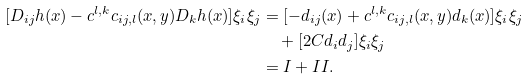Convert formula to latex. <formula><loc_0><loc_0><loc_500><loc_500>[ D _ { i j } h ( x ) - c ^ { l , k } c _ { i j , l } ( x , y ) D _ { k } h ( x ) ] \xi _ { i } \xi _ { j } & = [ - d _ { i j } ( x ) + c ^ { l , k } c _ { i j , l } ( x , y ) d _ { k } ( x ) ] \xi _ { i } \xi _ { j } \\ & \quad + [ 2 C d _ { i } d _ { j } ] \xi _ { i } \xi _ { j } \\ & = I + I I .</formula> 